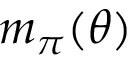Convert formula to latex. <formula><loc_0><loc_0><loc_500><loc_500>m _ { \pi } ( \theta )</formula> 